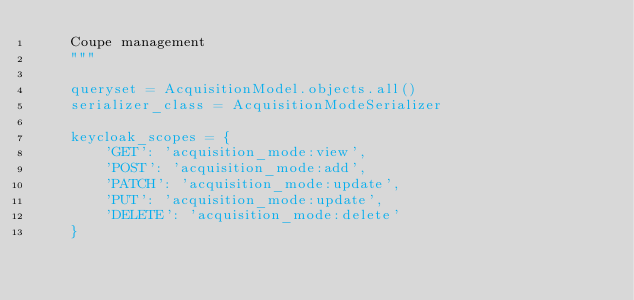<code> <loc_0><loc_0><loc_500><loc_500><_Python_>    Coupe management
    """

    queryset = AcquisitionModel.objects.all()
    serializer_class = AcquisitionModeSerializer

    keycloak_scopes = {
        'GET': 'acquisition_mode:view',
        'POST': 'acquisition_mode:add',
        'PATCH': 'acquisition_mode:update',
        'PUT': 'acquisition_mode:update',
        'DELETE': 'acquisition_mode:delete'
    }
</code> 